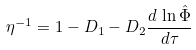<formula> <loc_0><loc_0><loc_500><loc_500>\eta ^ { - 1 } = 1 - D _ { 1 } - D _ { 2 } \frac { d \, \ln \hat { \Phi } } { d \tau }</formula> 